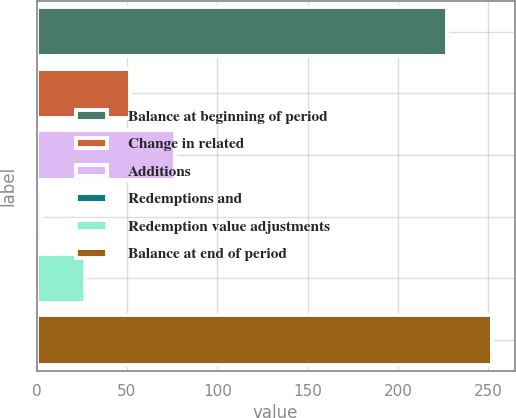Convert chart to OTSL. <chart><loc_0><loc_0><loc_500><loc_500><bar_chart><fcel>Balance at beginning of period<fcel>Change in related<fcel>Additions<fcel>Redemptions and<fcel>Redemption value adjustments<fcel>Balance at end of period<nl><fcel>227.2<fcel>51.66<fcel>76.34<fcel>2.3<fcel>26.98<fcel>251.88<nl></chart> 